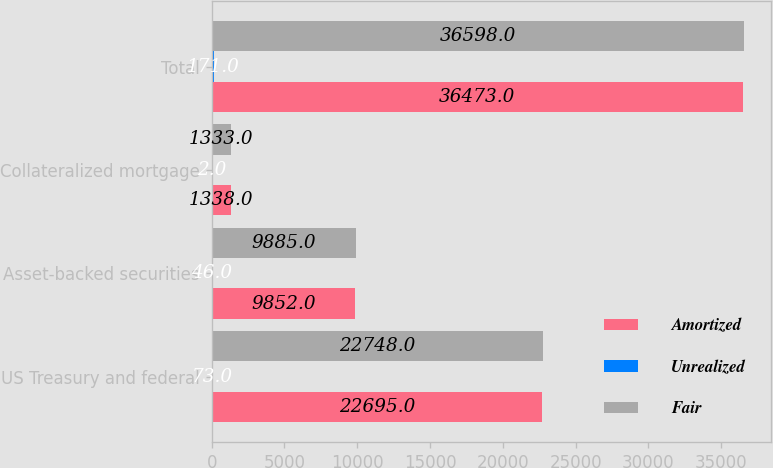Convert chart. <chart><loc_0><loc_0><loc_500><loc_500><stacked_bar_chart><ecel><fcel>US Treasury and federal<fcel>Asset-backed securities<fcel>Collateralized mortgage<fcel>Total<nl><fcel>Amortized<fcel>22695<fcel>9852<fcel>1338<fcel>36473<nl><fcel>Unrealized<fcel>73<fcel>46<fcel>2<fcel>171<nl><fcel>Fair<fcel>22748<fcel>9885<fcel>1333<fcel>36598<nl></chart> 